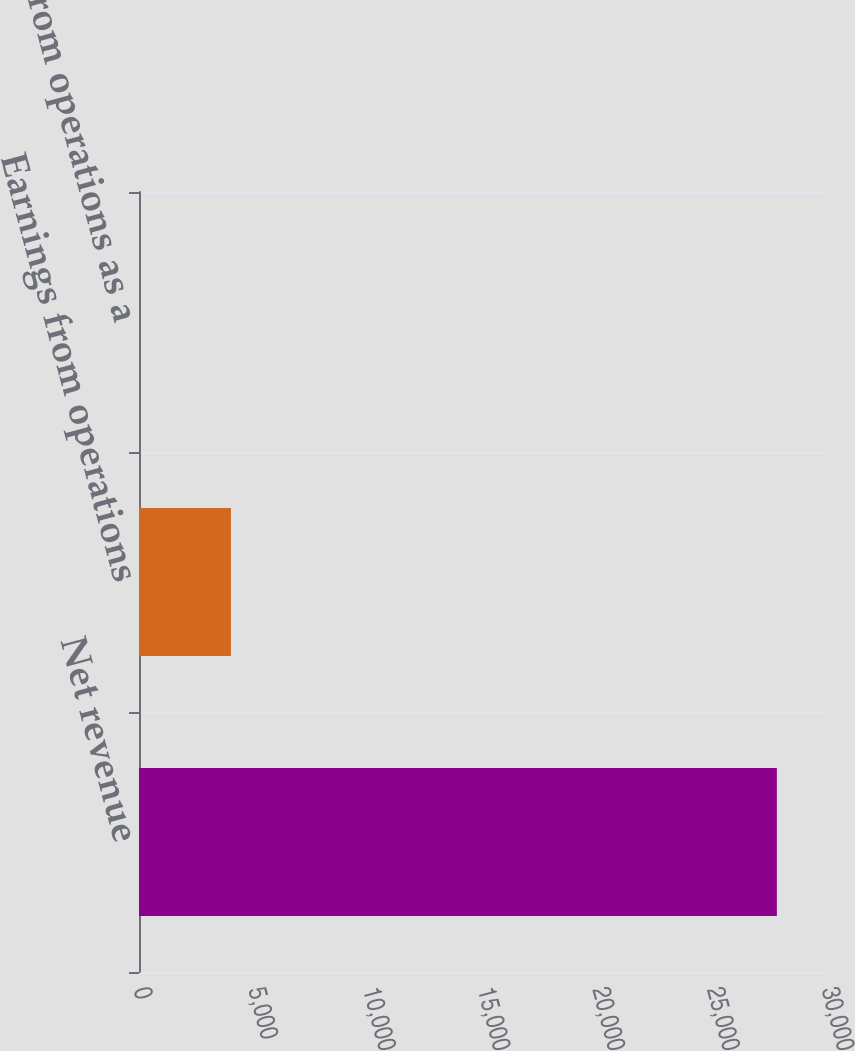Convert chart to OTSL. <chart><loc_0><loc_0><loc_500><loc_500><bar_chart><fcel>Net revenue<fcel>Earnings from operations<fcel>Earnings from operations as a<nl><fcel>27814<fcel>4008<fcel>14.4<nl></chart> 